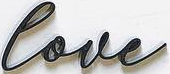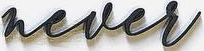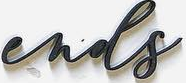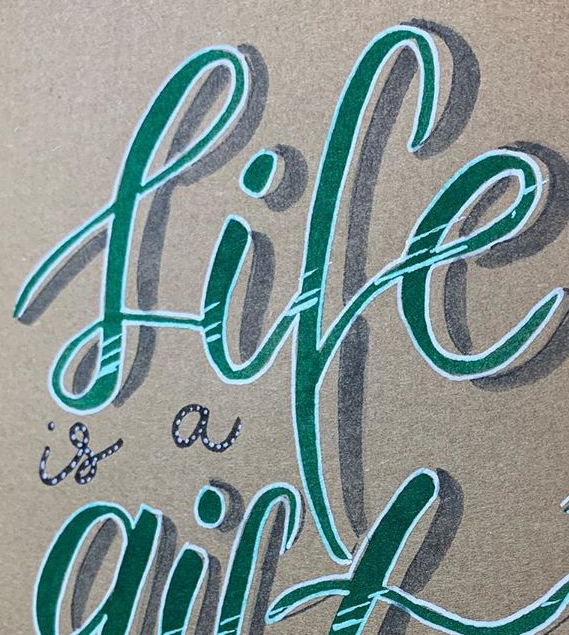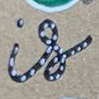What words are shown in these images in order, separated by a semicolon? love; never; ends; life; is 